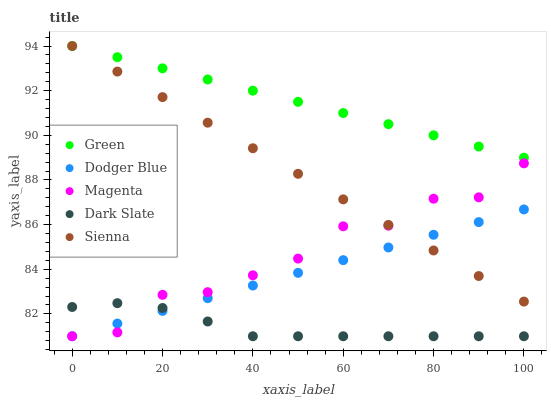Does Dark Slate have the minimum area under the curve?
Answer yes or no. Yes. Does Green have the maximum area under the curve?
Answer yes or no. Yes. Does Dodger Blue have the minimum area under the curve?
Answer yes or no. No. Does Dodger Blue have the maximum area under the curve?
Answer yes or no. No. Is Green the smoothest?
Answer yes or no. Yes. Is Magenta the roughest?
Answer yes or no. Yes. Is Dodger Blue the smoothest?
Answer yes or no. No. Is Dodger Blue the roughest?
Answer yes or no. No. Does Dodger Blue have the lowest value?
Answer yes or no. Yes. Does Green have the lowest value?
Answer yes or no. No. Does Green have the highest value?
Answer yes or no. Yes. Does Dodger Blue have the highest value?
Answer yes or no. No. Is Magenta less than Green?
Answer yes or no. Yes. Is Green greater than Dodger Blue?
Answer yes or no. Yes. Does Magenta intersect Dodger Blue?
Answer yes or no. Yes. Is Magenta less than Dodger Blue?
Answer yes or no. No. Is Magenta greater than Dodger Blue?
Answer yes or no. No. Does Magenta intersect Green?
Answer yes or no. No. 